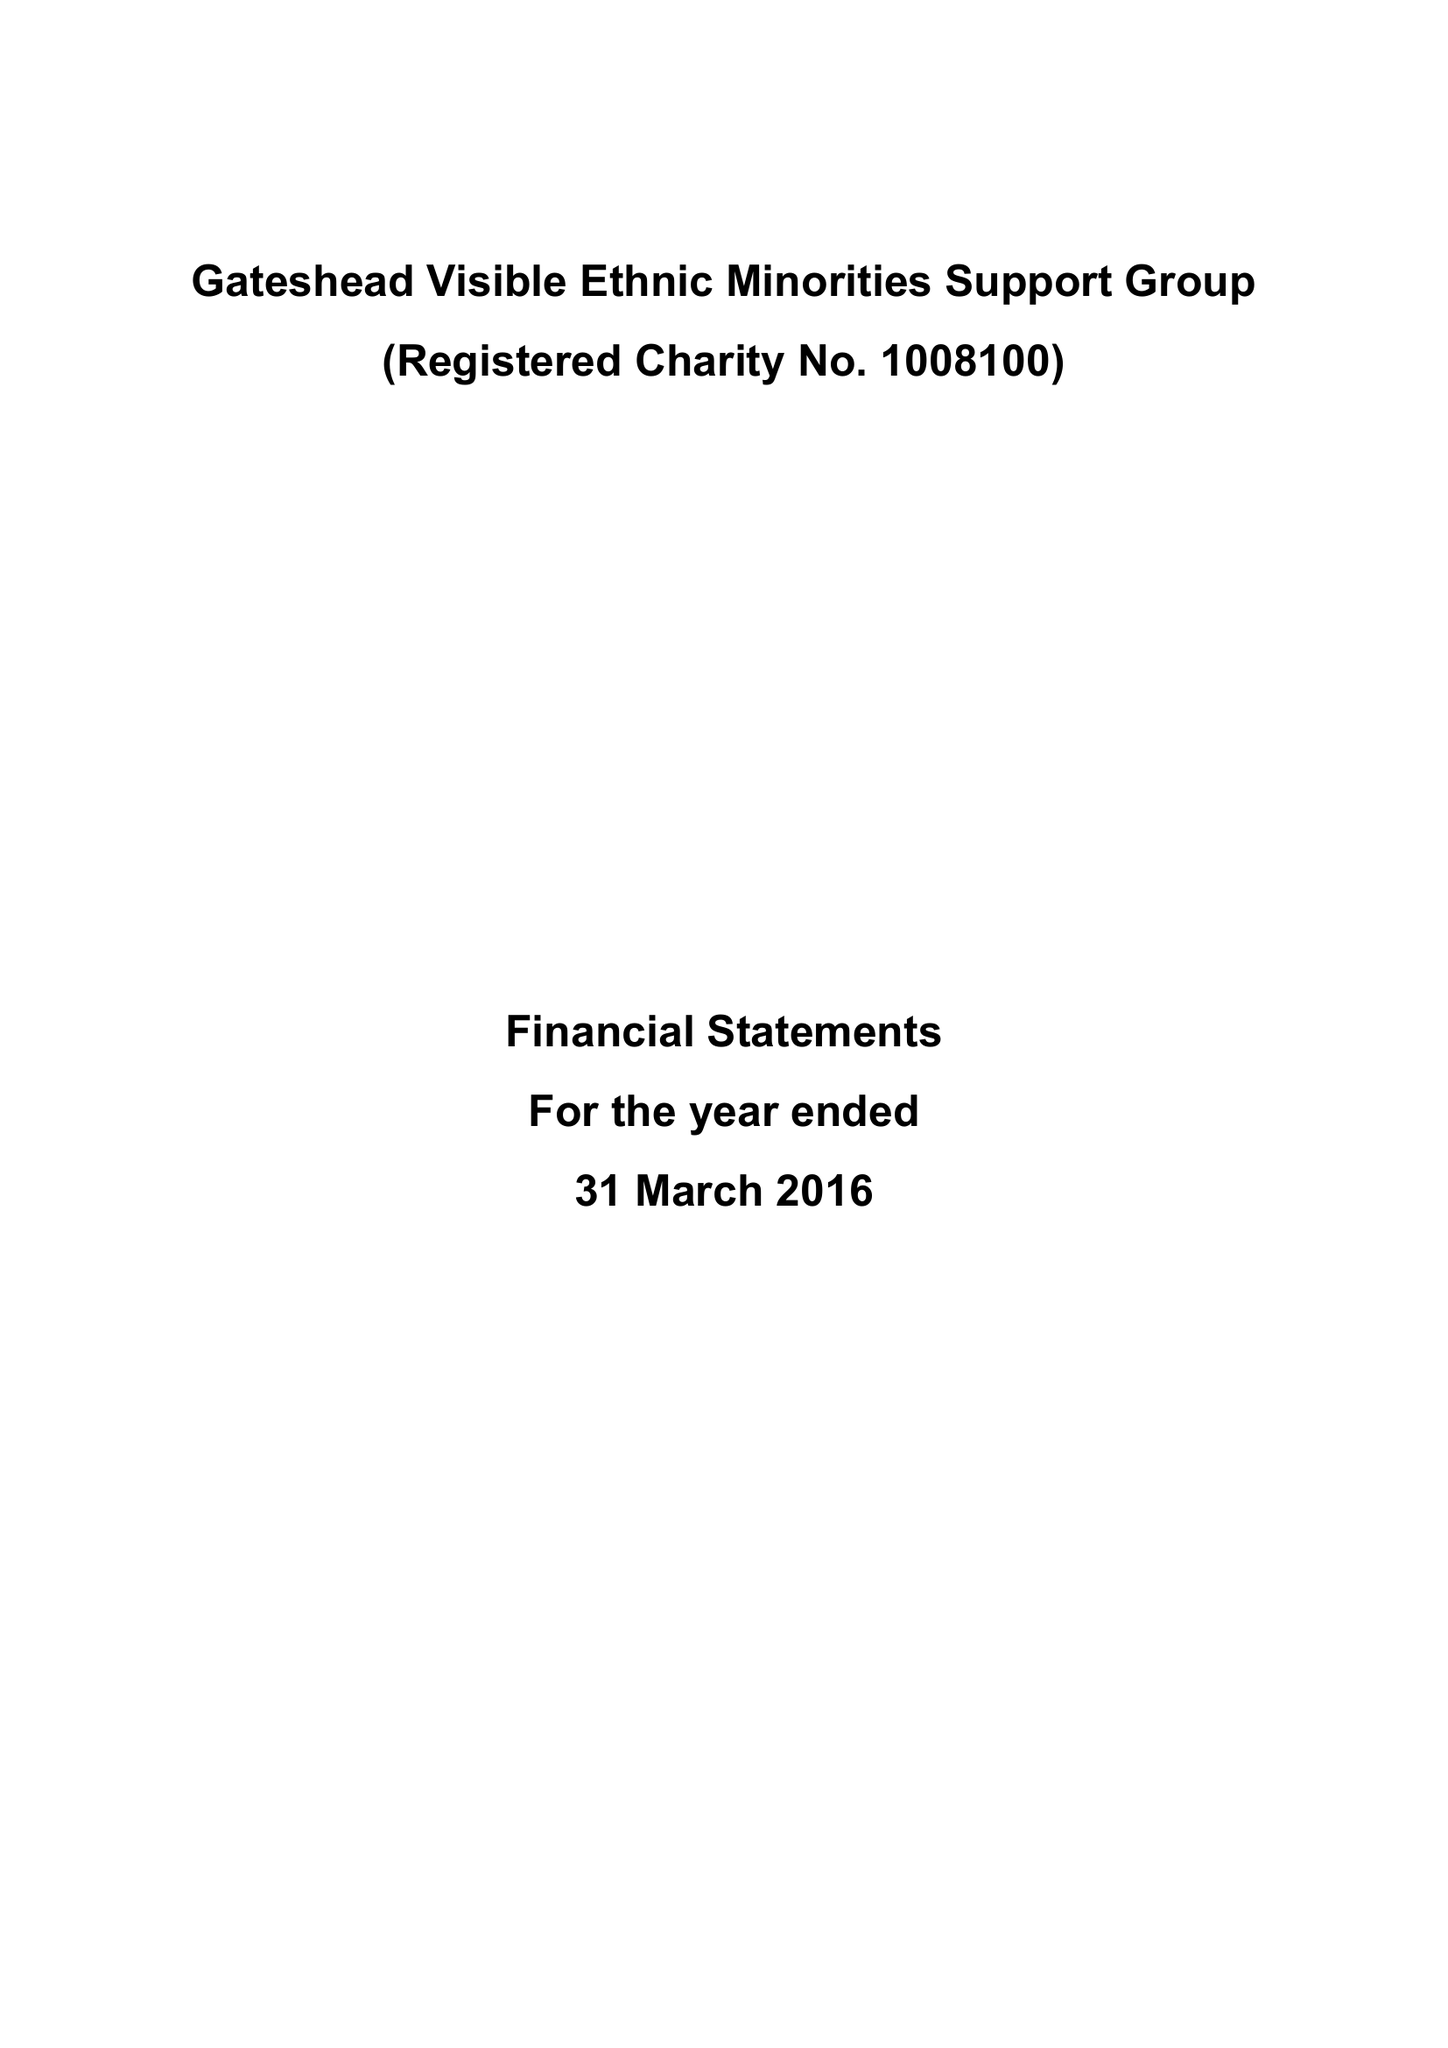What is the value for the address__street_line?
Answer the question using a single word or phrase. 2 FESTIVAL PARK DRIVE 